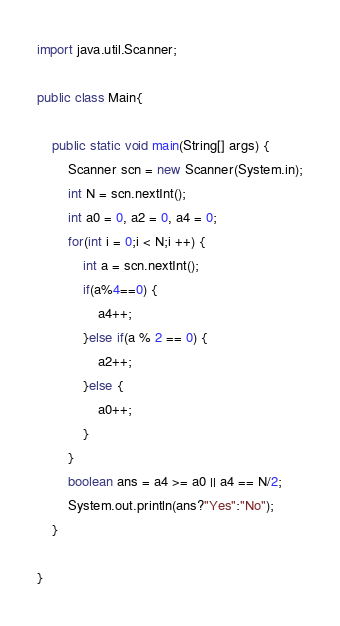<code> <loc_0><loc_0><loc_500><loc_500><_Java_>import java.util.Scanner;

public class Main{

	public static void main(String[] args) {
		Scanner scn = new Scanner(System.in);
		int N = scn.nextInt();
		int a0 = 0, a2 = 0, a4 = 0;
		for(int i = 0;i < N;i ++) {
			int a = scn.nextInt();
			if(a%4==0) {
				a4++;
			}else if(a % 2 == 0) {
				a2++;
			}else {
				a0++;
			}
		}
		boolean ans = a4 >= a0 || a4 == N/2;
		System.out.println(ans?"Yes":"No");
	}

}
</code> 